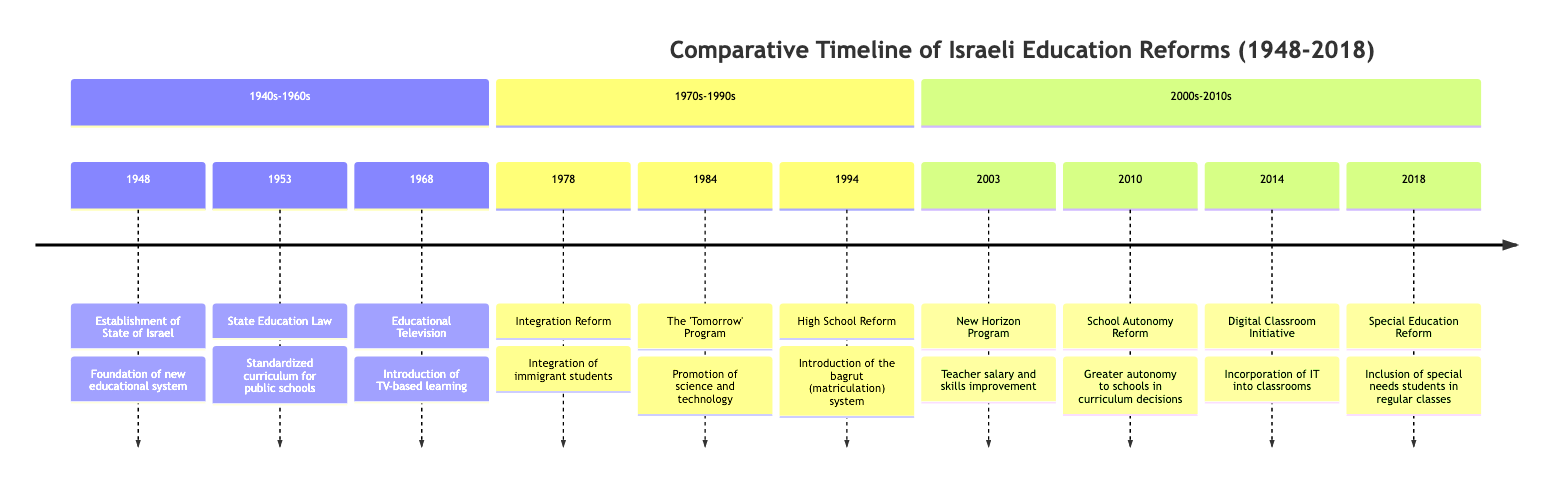What year was the State Education Law established? The diagram indicates that the State Education Law was established in 1953 under the section '1940s-1960s'.
Answer: 1953 Which reform occurred in 2014? Referring to the timeline, the reform that took place in 2014 is the Digital Classroom Initiative.
Answer: Digital Classroom Initiative How many education reforms are listed in the '2000s-2010s' section? By counting the nodes listed under the '2000s-2010s' section of the timeline, there are a total of four reforms: New Horizon Program, School Autonomy Reform, Digital Classroom Initiative, and Special Education Reform.
Answer: 4 What is the primary focus of the 'Tomorrow' Program introduced in 1984? The diagram states that the 'Tomorrow' Program was introduced in 1984 with the focus on promoting science and technology within the education system.
Answer: Science and technology Which reform aimed at integrating immigrant students, and in what year was it implemented? The timeline shows that the Integration Reform aimed at integrating immigrant students and was implemented in 1978.
Answer: Integration Reform, 1978 What type of learning method was introduced in 1968? The diagram states that Educational Television, introduced in 1968, signifies a shift to a TV-based learning method.
Answer: TV-based learning In which section is the Special Education Reform found? By examining the timeline structure, the Special Education Reform is found in the '2000s-2010s' section.
Answer: 2000s-2010s Identify one significant change from the High School Reform of 1994. The High School Reform, introduced in 1994, is significant for its introduction of the bagrut (matriculation) system into high school education.
Answer: Bagrut (matriculation) system Which two reforms focus on the improvement of teachers or school autonomy? The New Horizon Program (2003) focuses on teacher salary and skills improvement, and the School Autonomy Reform (2010) grants greater autonomy to schools.
Answer: New Horizon Program, School Autonomy Reform What reform was aimed at special needs students and when was it enacted? The diagram specifies that the Special Education Reform aimed to include special needs students in regular classes and was enacted in 2018.
Answer: Special Education Reform, 2018 